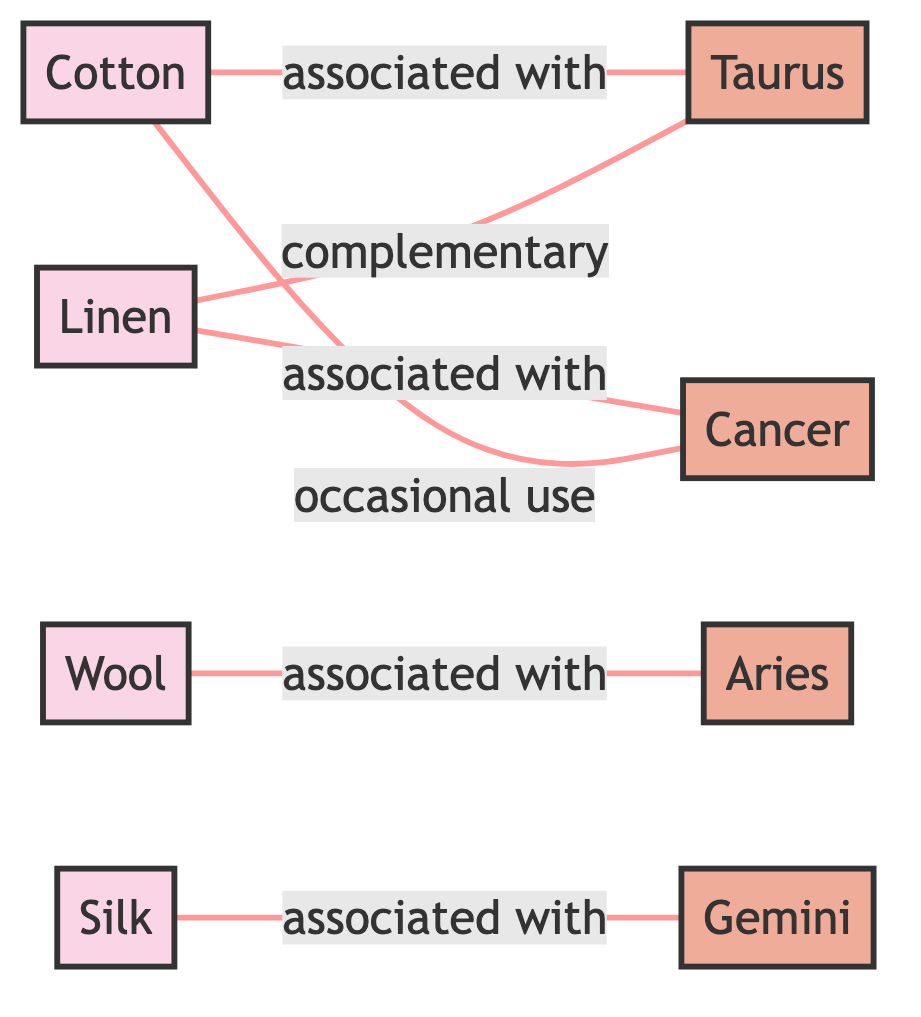What's the total number of nodes in the diagram? The diagram contains a list of nodes representing textile materials and zodiac symbols. By counting, we find there are eight nodes total: four materials (Cotton, Wool, Silk, Linen) and four zodiac signs (Aries, Taurus, Gemini, Cancer).
Answer: Eight Which zodiac sign is associated with Wool? The diagram shows a direct edge connecting Wool to Aries with the relationship labeled as "associated with." Therefore, the zodiac sign associated with Wool is Aries.
Answer: Aries How many relationships are shown between Cotton and zodiac symbols? The relationships involving Cotton can be examined by looking at the edges connected to Cotton. Cotton is associated with Taurus and has an occasional use relationship with Cancer, totaling two relationships with zodiac symbols.
Answer: Two What material is complementary to Taurus? Looking at the edges, Linen is connected to Taurus with a "complementary" relationship. Therefore, the material that is complementary to Taurus is Linen.
Answer: Linen Which zodiac sign is Silk associated with? Silk is directly connected to Gemini in the diagram by an edge with the "associated with" label. Therefore, the zodiac sign associated with Silk is Gemini.
Answer: Gemini Is Cotton used occasionally with Cancer? Yes, the diagram displays a connection from Cotton to Cancer with the relationship labeled "occasional use," indicating that it is sometimes used alongside Cancer.
Answer: Yes What type of relationship exists between Linen and Taurus? The edge between Linen and Taurus is labeled "complementary," indicating a positive, supportive relationship where Linen complements Taurus.
Answer: Complementary How many edges connect materials to zodiac symbols? By examining the connections in the diagram, we find there are six edges in total linking materials (Cotton, Wool, Silk, Linen) to zodiac symbols (Aries, Taurus, Gemini, Cancer).
Answer: Six 